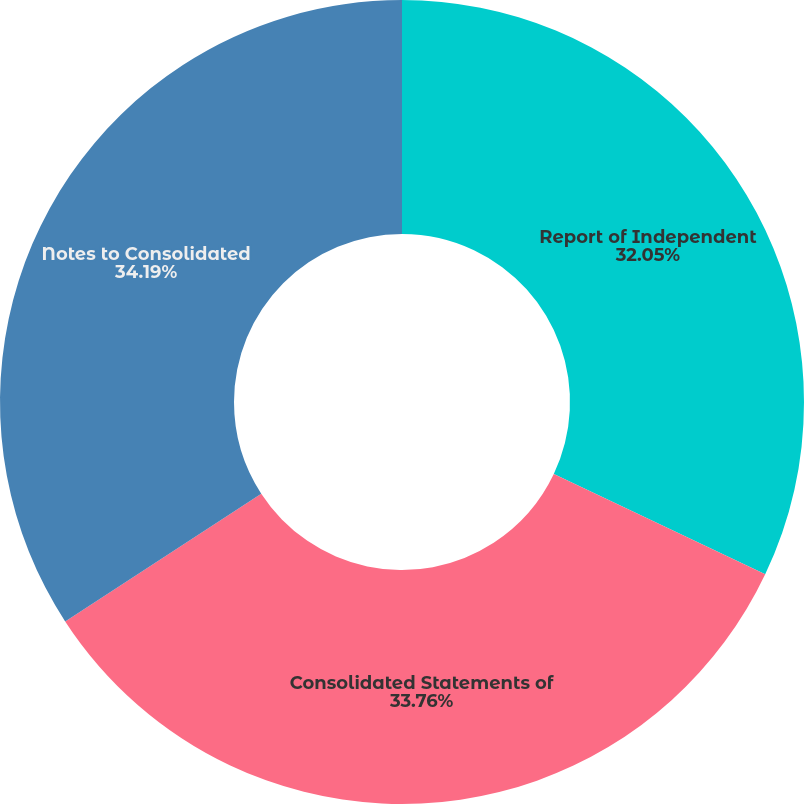Convert chart to OTSL. <chart><loc_0><loc_0><loc_500><loc_500><pie_chart><fcel>Report of Independent<fcel>Consolidated Statements of<fcel>Notes to Consolidated<nl><fcel>32.05%<fcel>33.76%<fcel>34.19%<nl></chart> 